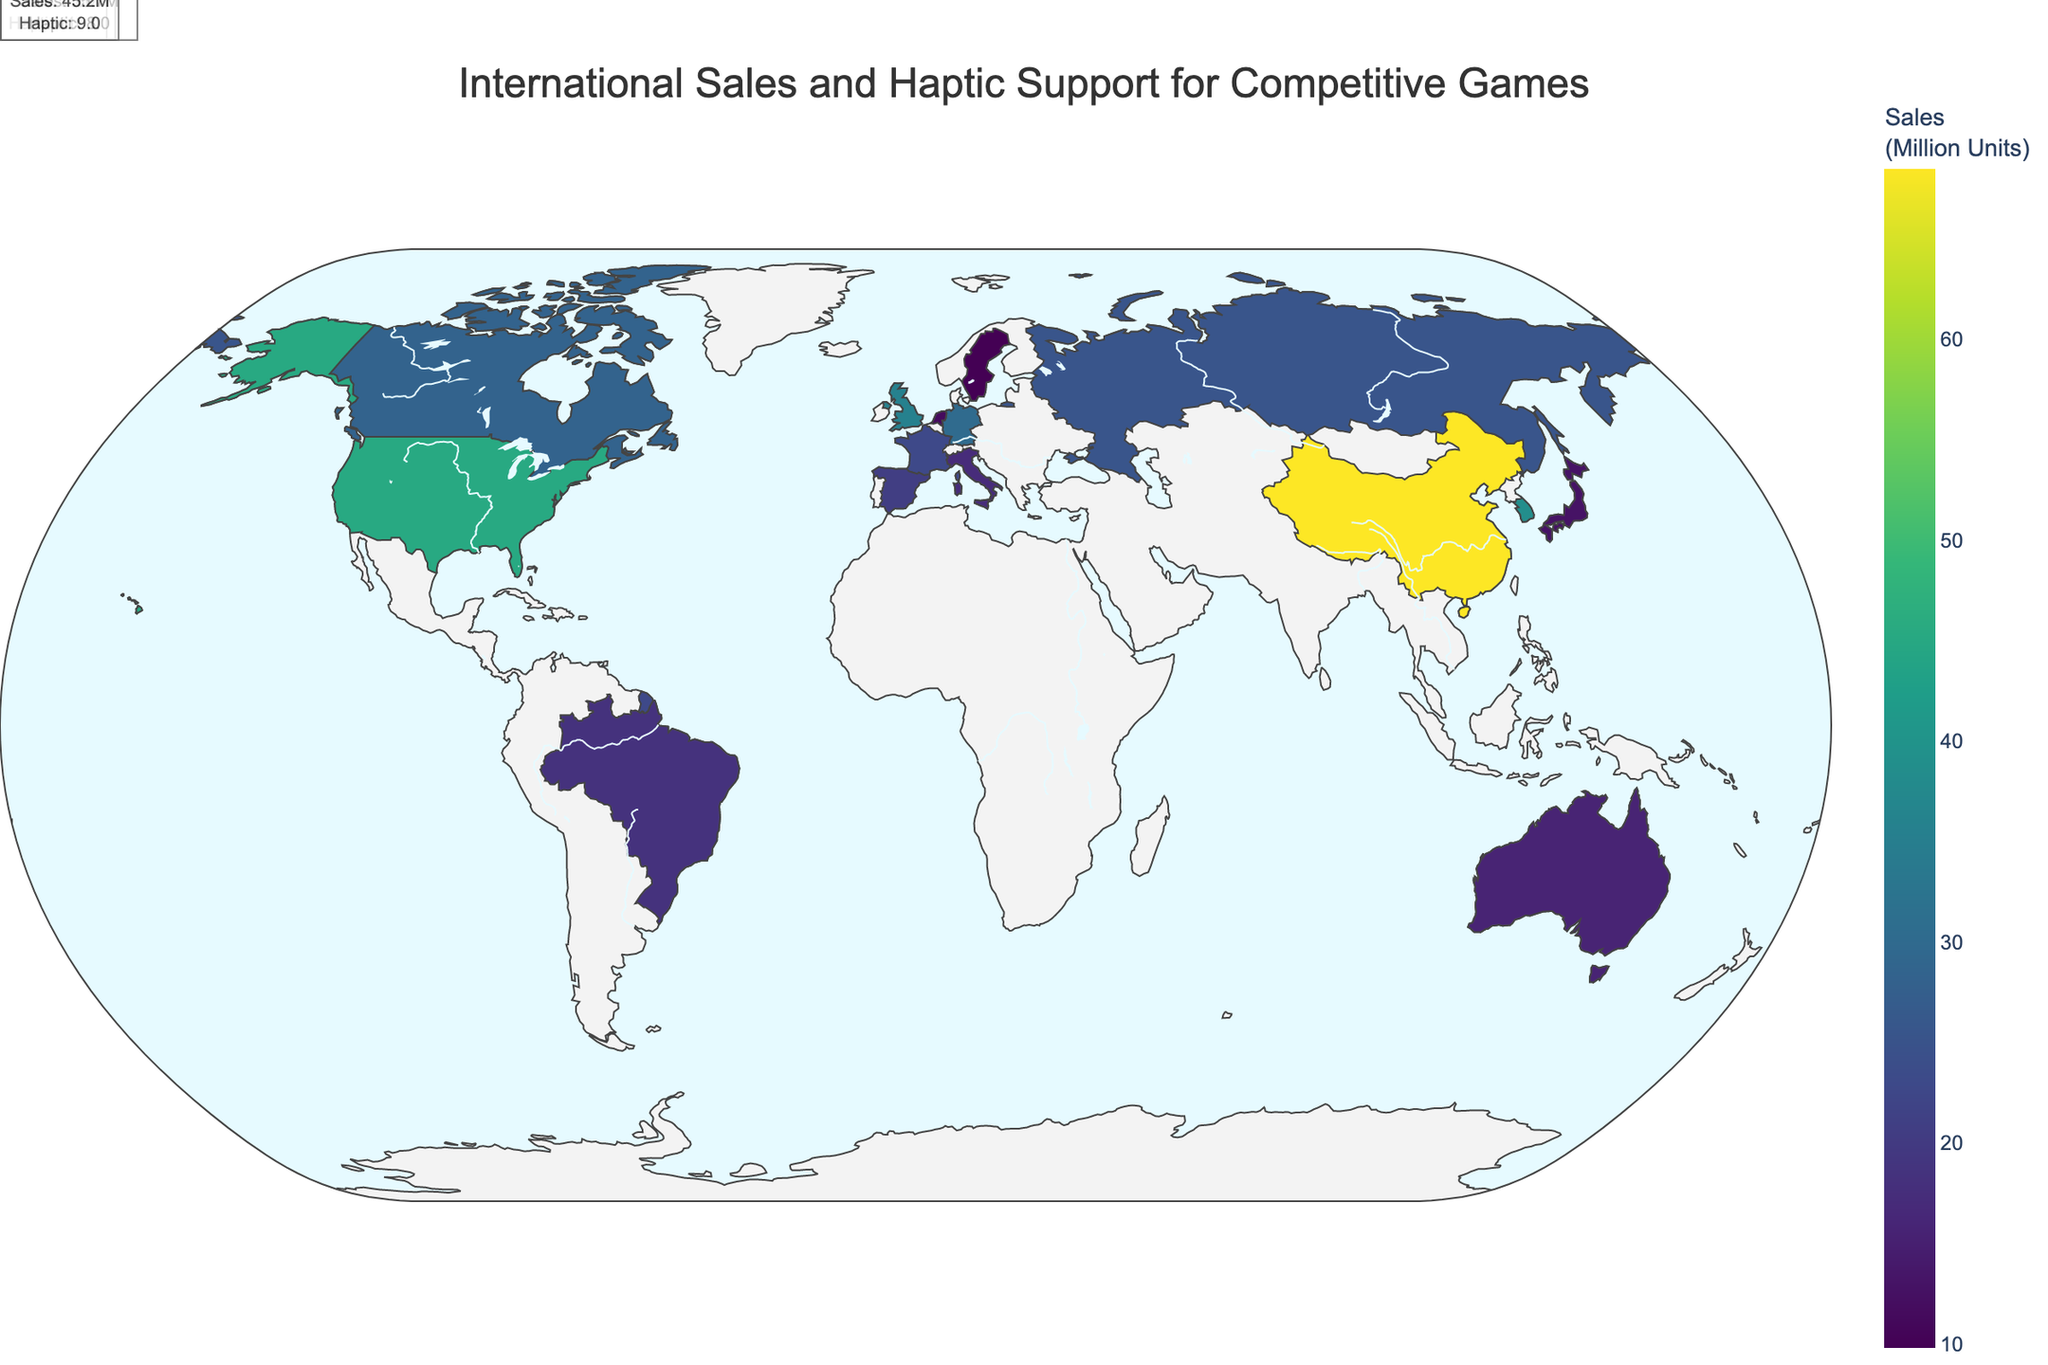What's the title of the figure? The title can be found at the top center of the figure. Simply read the text that is displayed there.
Answer: International Sales and Haptic Support for Competitive Games Which country has the highest game sales? Look at the data points on the map and find the country with the highest sales value.
Answer: China What is the haptic support rating for the game with the highest sales in the United Kingdom? Locate the United Kingdom on the map. Check the hover information or annotation for the haptic support rating.
Answer: 8 What's the average haptic support rating for games in countries with over 30 million units sold? Identify countries with over 30 million units sold (China, United States, South Korea, Germany, United Kingdom). Sum their haptic ratings (9, 9, 7, 6, 8 = 39) and divide by the number of these countries (5).
Answer: 7.8 Which country has the lowest haptic support rating and what is its sales figure? Find the country with the lowest haptic support rating by comparing each country’s ratings. The respective sales figure can be found in the hover information or annotation.
Answer: Germany, 30.1 million units How much higher are the game sales in China compared to the United States? Find the sales figures for China and the United States, then subtract the U.S. sales from China's sales (68.5 - 45.2).
Answer: 23.3 million units Which two countries have the closest game sales figures and what are those values? Compare the sales figures of all countries to determine which two are closest to each other.
Answer: Italy and Brazil; 17.2 and 18.3 million units What is the total sales for all countries combined? Sum the sales figures for all countries mentioned in the data (45.2 + 12.8 + 38.6 + 30.1 + 68.5 + 35.7 + 18.3 + 22.9 + 25.4 + 15.6 + 28.3 + 20.7 + 17.2 + 9.8 + 11.5).
Answer: 400.6 million units Which country excels in both high sales and high haptic support rating? Evaluate both sales figures and haptic ratings to identify the country which is strong in both areas. High sales > 20 million, high haptic rating > 8.
Answer: China How does the haptic support rating for the game in Canada compare to that in France? Locate Canada and France on the map and compare their haptic support ratings as displayed in their annotations.
Answer: Both are 9 